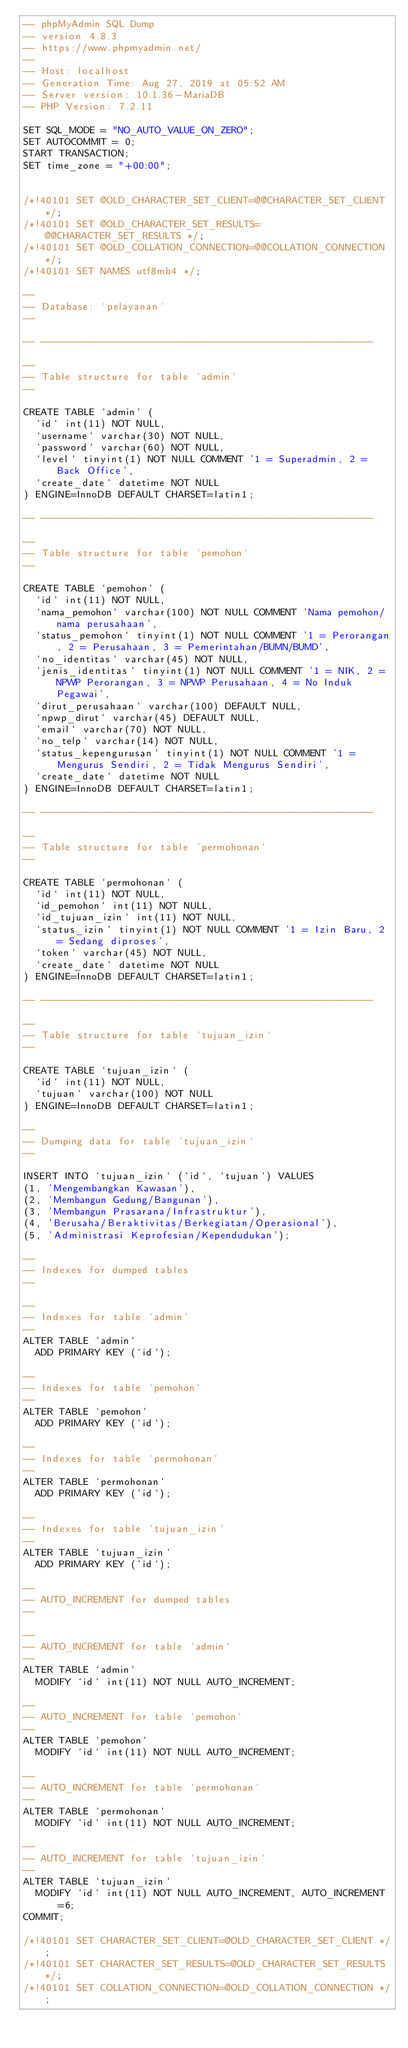<code> <loc_0><loc_0><loc_500><loc_500><_SQL_>-- phpMyAdmin SQL Dump
-- version 4.8.3
-- https://www.phpmyadmin.net/
--
-- Host: localhost
-- Generation Time: Aug 27, 2019 at 05:52 AM
-- Server version: 10.1.36-MariaDB
-- PHP Version: 7.2.11

SET SQL_MODE = "NO_AUTO_VALUE_ON_ZERO";
SET AUTOCOMMIT = 0;
START TRANSACTION;
SET time_zone = "+00:00";


/*!40101 SET @OLD_CHARACTER_SET_CLIENT=@@CHARACTER_SET_CLIENT */;
/*!40101 SET @OLD_CHARACTER_SET_RESULTS=@@CHARACTER_SET_RESULTS */;
/*!40101 SET @OLD_COLLATION_CONNECTION=@@COLLATION_CONNECTION */;
/*!40101 SET NAMES utf8mb4 */;

--
-- Database: `pelayanan`
--

-- --------------------------------------------------------

--
-- Table structure for table `admin`
--

CREATE TABLE `admin` (
  `id` int(11) NOT NULL,
  `username` varchar(30) NOT NULL,
  `password` varchar(60) NOT NULL,
  `level` tinyint(1) NOT NULL COMMENT '1 = Superadmin, 2 = Back Office',
  `create_date` datetime NOT NULL
) ENGINE=InnoDB DEFAULT CHARSET=latin1;

-- --------------------------------------------------------

--
-- Table structure for table `pemohon`
--

CREATE TABLE `pemohon` (
  `id` int(11) NOT NULL,
  `nama_pemohon` varchar(100) NOT NULL COMMENT 'Nama pemohon/nama perusahaan',
  `status_pemohon` tinyint(1) NOT NULL COMMENT '1 = Perorangan, 2 = Perusahaan, 3 = Pemerintahan/BUMN/BUMD',
  `no_identitas` varchar(45) NOT NULL,
  `jenis_identitas` tinyint(1) NOT NULL COMMENT '1 = NIK, 2 = NPWP Perorangan, 3 = NPWP Perusahaan, 4 = No Induk Pegawai',
  `dirut_perusahaan` varchar(100) DEFAULT NULL,
  `npwp_dirut` varchar(45) DEFAULT NULL,
  `email` varchar(70) NOT NULL,
  `no_telp` varchar(14) NOT NULL,
  `status_kepengurusan` tinyint(1) NOT NULL COMMENT '1 = Mengurus Sendiri, 2 = Tidak Mengurus Sendiri',
  `create_date` datetime NOT NULL
) ENGINE=InnoDB DEFAULT CHARSET=latin1;

-- --------------------------------------------------------

--
-- Table structure for table `permohonan`
--

CREATE TABLE `permohonan` (
  `id` int(11) NOT NULL,
  `id_pemohon` int(11) NOT NULL,
  `id_tujuan_izin` int(11) NOT NULL,
  `status_izin` tinyint(1) NOT NULL COMMENT '1 = Izin Baru, 2 = Sedang diproses',
  `token` varchar(45) NOT NULL,
  `create_date` datetime NOT NULL
) ENGINE=InnoDB DEFAULT CHARSET=latin1;

-- --------------------------------------------------------

--
-- Table structure for table `tujuan_izin`
--

CREATE TABLE `tujuan_izin` (
  `id` int(11) NOT NULL,
  `tujuan` varchar(100) NOT NULL
) ENGINE=InnoDB DEFAULT CHARSET=latin1;

--
-- Dumping data for table `tujuan_izin`
--

INSERT INTO `tujuan_izin` (`id`, `tujuan`) VALUES
(1, 'Mengembangkan Kawasan'),
(2, 'Membangun Gedung/Bangunan'),
(3, 'Membangun Prasarana/Infrastruktur'),
(4, 'Berusaha/Beraktivitas/Berkegiatan/Operasional'),
(5, 'Administrasi Keprofesian/Kependudukan');

--
-- Indexes for dumped tables
--

--
-- Indexes for table `admin`
--
ALTER TABLE `admin`
  ADD PRIMARY KEY (`id`);

--
-- Indexes for table `pemohon`
--
ALTER TABLE `pemohon`
  ADD PRIMARY KEY (`id`);

--
-- Indexes for table `permohonan`
--
ALTER TABLE `permohonan`
  ADD PRIMARY KEY (`id`);

--
-- Indexes for table `tujuan_izin`
--
ALTER TABLE `tujuan_izin`
  ADD PRIMARY KEY (`id`);

--
-- AUTO_INCREMENT for dumped tables
--

--
-- AUTO_INCREMENT for table `admin`
--
ALTER TABLE `admin`
  MODIFY `id` int(11) NOT NULL AUTO_INCREMENT;

--
-- AUTO_INCREMENT for table `pemohon`
--
ALTER TABLE `pemohon`
  MODIFY `id` int(11) NOT NULL AUTO_INCREMENT;

--
-- AUTO_INCREMENT for table `permohonan`
--
ALTER TABLE `permohonan`
  MODIFY `id` int(11) NOT NULL AUTO_INCREMENT;

--
-- AUTO_INCREMENT for table `tujuan_izin`
--
ALTER TABLE `tujuan_izin`
  MODIFY `id` int(11) NOT NULL AUTO_INCREMENT, AUTO_INCREMENT=6;
COMMIT;

/*!40101 SET CHARACTER_SET_CLIENT=@OLD_CHARACTER_SET_CLIENT */;
/*!40101 SET CHARACTER_SET_RESULTS=@OLD_CHARACTER_SET_RESULTS */;
/*!40101 SET COLLATION_CONNECTION=@OLD_COLLATION_CONNECTION */;
</code> 